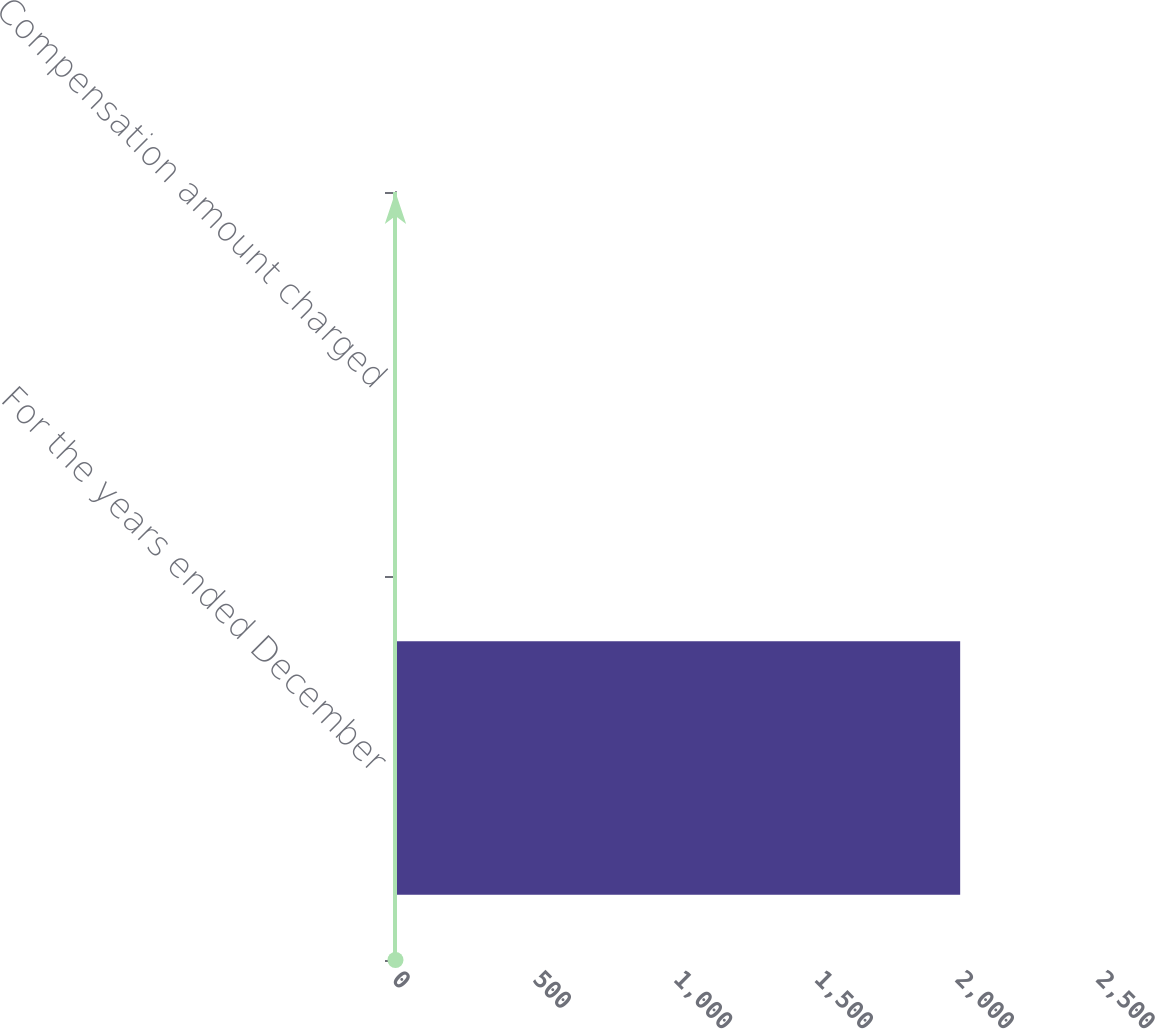Convert chart. <chart><loc_0><loc_0><loc_500><loc_500><bar_chart><fcel>For the years ended December<fcel>Compensation amount charged<nl><fcel>2007<fcel>1.7<nl></chart> 